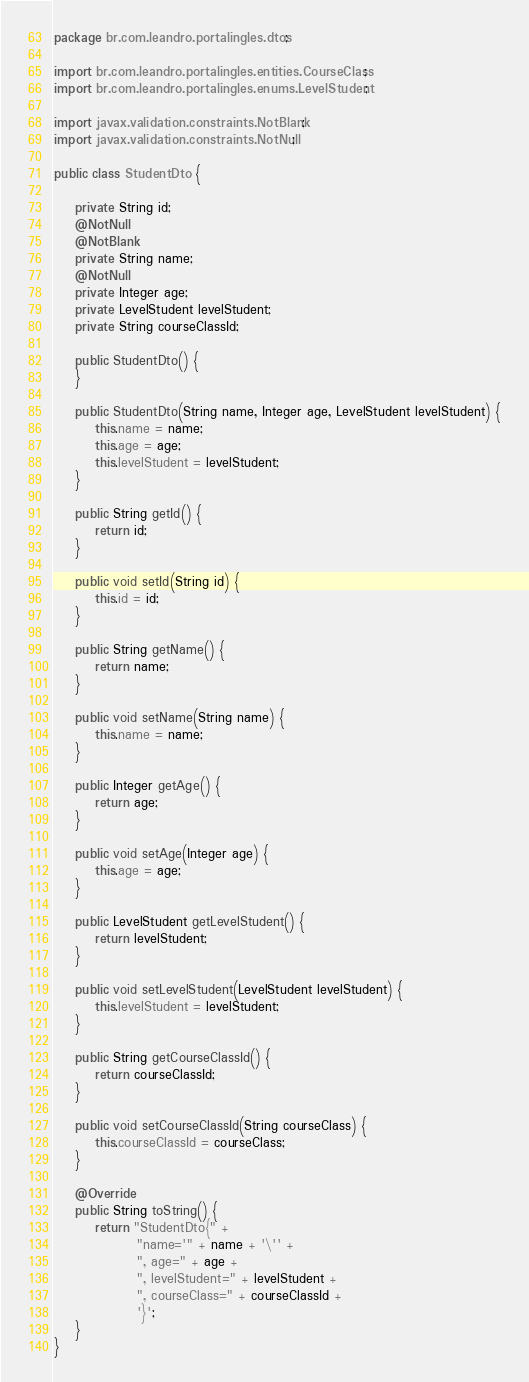<code> <loc_0><loc_0><loc_500><loc_500><_Java_>package br.com.leandro.portalingles.dtos;

import br.com.leandro.portalingles.entities.CourseClass;
import br.com.leandro.portalingles.enums.LevelStudent;

import javax.validation.constraints.NotBlank;
import javax.validation.constraints.NotNull;

public class StudentDto {

    private String id;
    @NotNull
    @NotBlank
    private String name;
    @NotNull
    private Integer age;
    private LevelStudent levelStudent;
    private String courseClassId;

    public StudentDto() {
    }

    public StudentDto(String name, Integer age, LevelStudent levelStudent) {
        this.name = name;
        this.age = age;
        this.levelStudent = levelStudent;
    }

    public String getId() {
        return id;
    }

    public void setId(String id) {
        this.id = id;
    }

    public String getName() {
        return name;
    }

    public void setName(String name) {
        this.name = name;
    }

    public Integer getAge() {
        return age;
    }

    public void setAge(Integer age) {
        this.age = age;
    }

    public LevelStudent getLevelStudent() {
        return levelStudent;
    }

    public void setLevelStudent(LevelStudent levelStudent) {
        this.levelStudent = levelStudent;
    }

    public String getCourseClassId() {
        return courseClassId;
    }

    public void setCourseClassId(String courseClass) {
        this.courseClassId = courseClass;
    }

    @Override
    public String toString() {
        return "StudentDto{" +
                "name='" + name + '\'' +
                ", age=" + age +
                ", levelStudent=" + levelStudent +
                ", courseClass=" + courseClassId +
                '}';
    }
}
</code> 